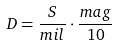Convert formula to latex. <formula><loc_0><loc_0><loc_500><loc_500>D = \frac { S } { m i l } \cdot \frac { m a g } { 1 0 }</formula> 